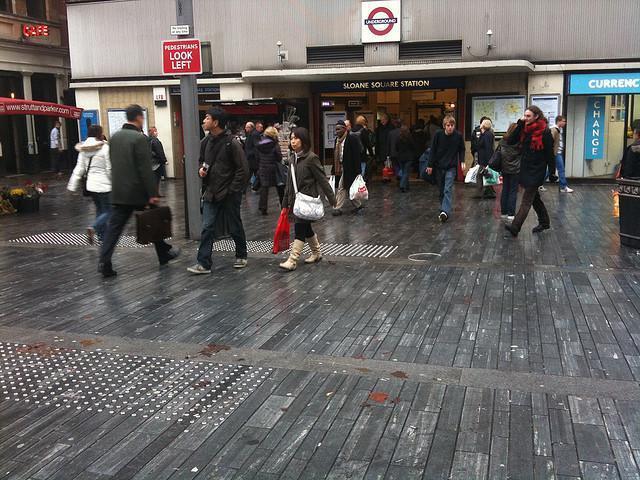How many people are there?
Give a very brief answer. 7. 